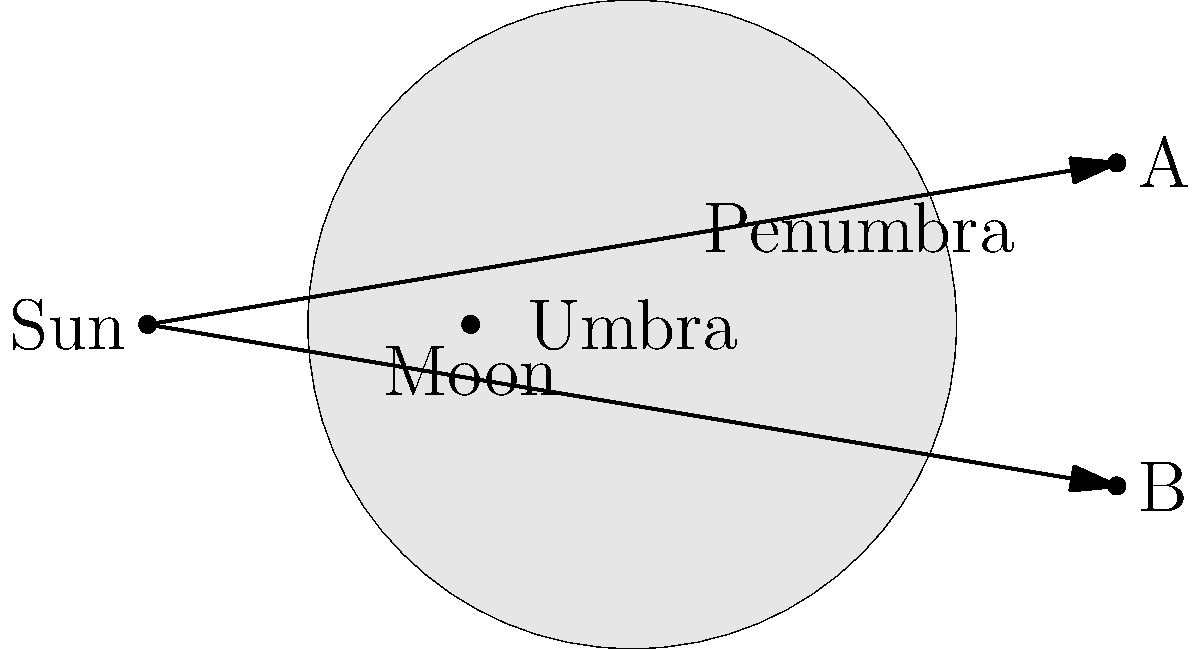During a solar eclipse, observers at points A and B on Earth's surface will experience different phenomena. What type of eclipse will be visible from point A, and how does it differ from what an observer at point B would see? Let's analyze the diagram step-by-step:

1. The diagram shows the Sun, Moon, and Earth during a solar eclipse.

2. The Moon casts two shadows:
   a) The umbra: the darkest, inner shadow
   b) The penumbra: the lighter, outer shadow

3. Point A is located outside both the umbra and penumbra:
   - This observer will not see any part of the eclipse
   - The Sun will appear normal from this location

4. Point B is within the penumbra:
   - This observer will see a partial solar eclipse
   - Part of the Sun's disk will be obscured by the Moon, but not completely

5. The difference between A and B:
   - A: No eclipse visible
   - B: Partial solar eclipse visible

6. Neither point is in the umbra, so a total solar eclipse won't be visible from either location.

In Roma culture, celestial events like eclipses have often been regarded with significance. Understanding these phenomena can help community leaders dispel myths and provide accurate information to their people.
Answer: A: No eclipse; B: Partial solar eclipse 